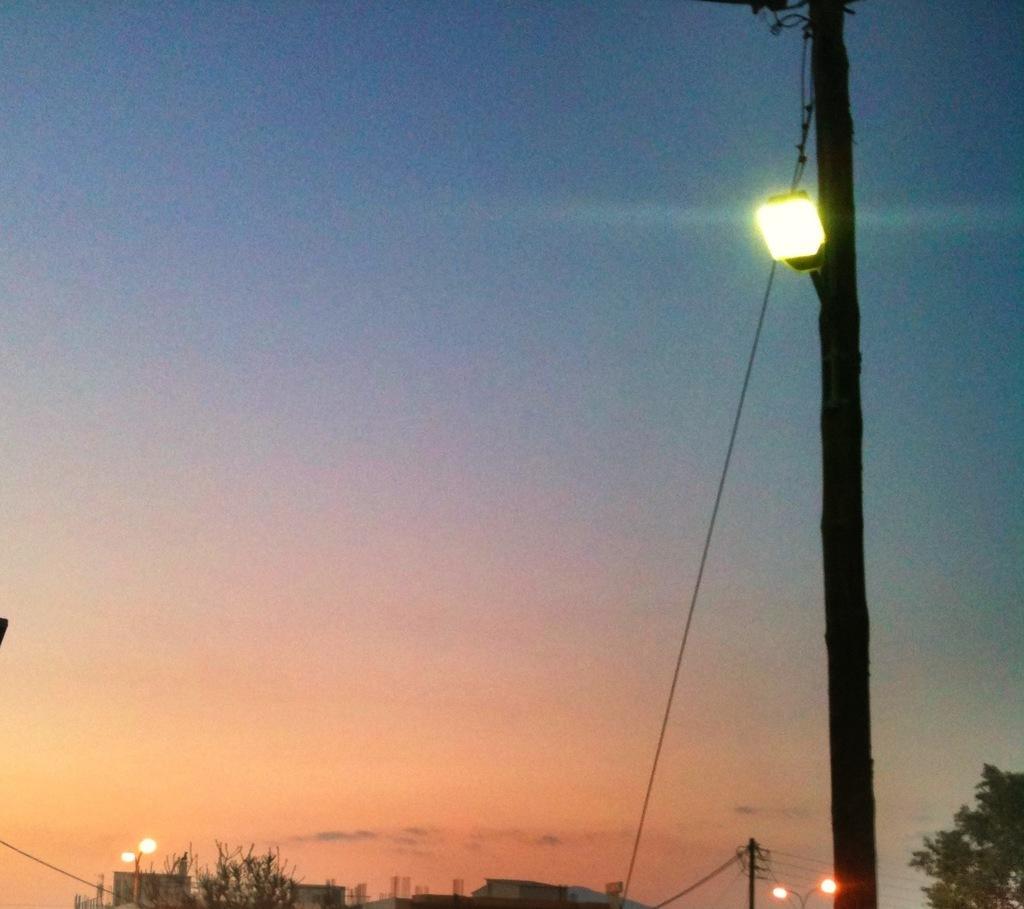Could you give a brief overview of what you see in this image? In this picture we can see buildings, trees, lights, poles and in the background we can see the sky. 